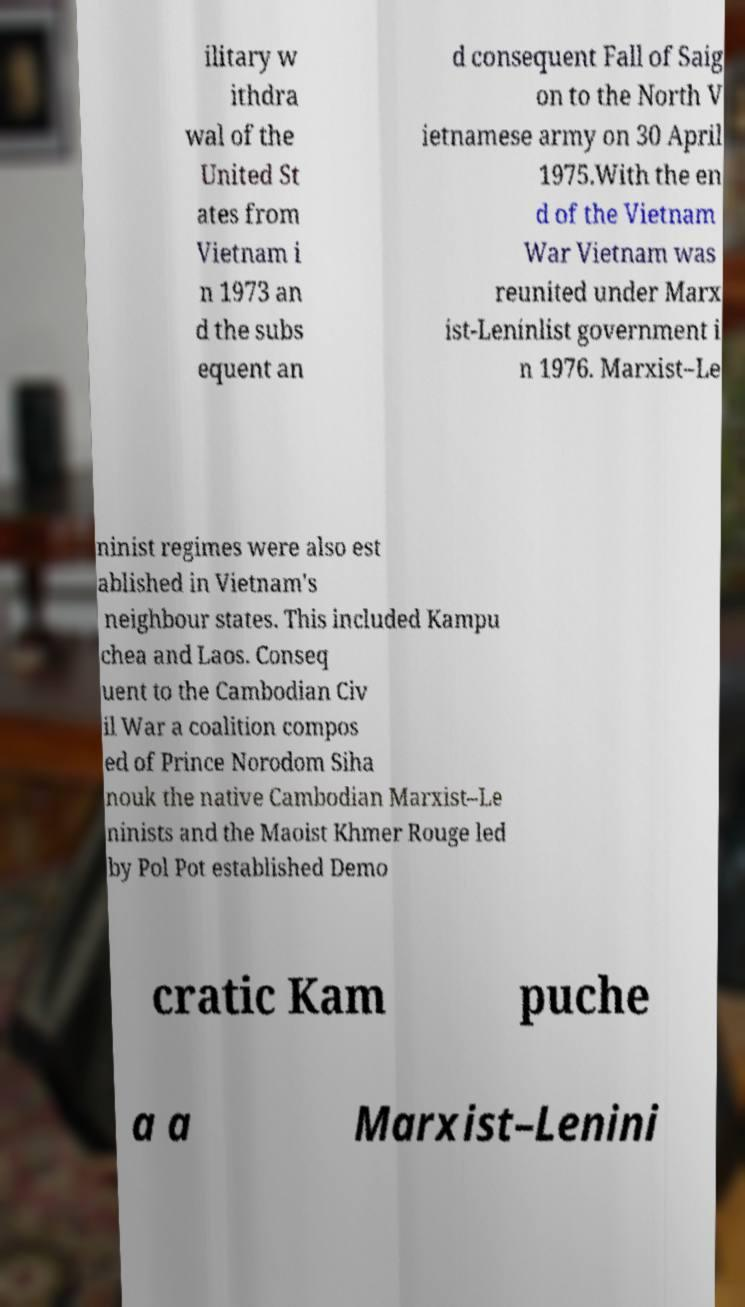Could you extract and type out the text from this image? ilitary w ithdra wal of the United St ates from Vietnam i n 1973 an d the subs equent an d consequent Fall of Saig on to the North V ietnamese army on 30 April 1975.With the en d of the Vietnam War Vietnam was reunited under Marx ist-Leninlist government i n 1976. Marxist–Le ninist regimes were also est ablished in Vietnam's neighbour states. This included Kampu chea and Laos. Conseq uent to the Cambodian Civ il War a coalition compos ed of Prince Norodom Siha nouk the native Cambodian Marxist–Le ninists and the Maoist Khmer Rouge led by Pol Pot established Demo cratic Kam puche a a Marxist–Lenini 